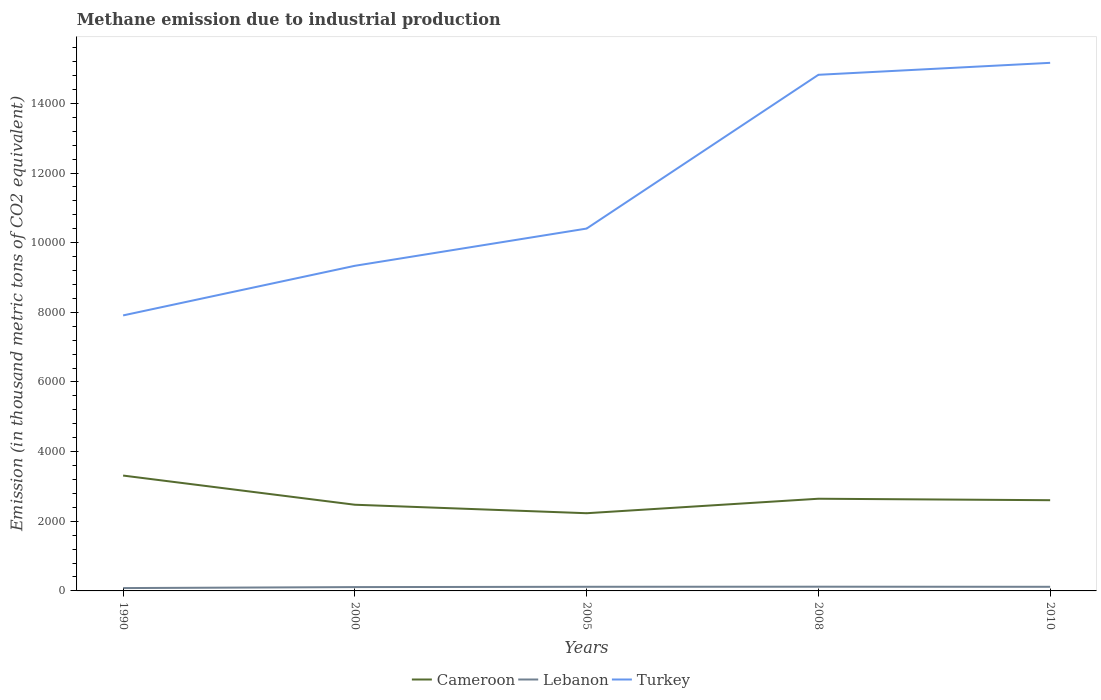Across all years, what is the maximum amount of methane emitted in Cameroon?
Make the answer very short. 2231.4. What is the difference between the highest and the second highest amount of methane emitted in Cameroon?
Make the answer very short. 1081.7. What is the difference between the highest and the lowest amount of methane emitted in Turkey?
Provide a short and direct response. 2. How many lines are there?
Keep it short and to the point. 3. What is the difference between two consecutive major ticks on the Y-axis?
Ensure brevity in your answer.  2000. Are the values on the major ticks of Y-axis written in scientific E-notation?
Give a very brief answer. No. What is the title of the graph?
Your response must be concise. Methane emission due to industrial production. What is the label or title of the X-axis?
Your answer should be very brief. Years. What is the label or title of the Y-axis?
Give a very brief answer. Emission (in thousand metric tons of CO2 equivalent). What is the Emission (in thousand metric tons of CO2 equivalent) of Cameroon in 1990?
Your response must be concise. 3313.1. What is the Emission (in thousand metric tons of CO2 equivalent) in Lebanon in 1990?
Provide a succinct answer. 81.7. What is the Emission (in thousand metric tons of CO2 equivalent) in Turkey in 1990?
Keep it short and to the point. 7912.1. What is the Emission (in thousand metric tons of CO2 equivalent) of Cameroon in 2000?
Keep it short and to the point. 2475.1. What is the Emission (in thousand metric tons of CO2 equivalent) of Lebanon in 2000?
Ensure brevity in your answer.  109.7. What is the Emission (in thousand metric tons of CO2 equivalent) in Turkey in 2000?
Keep it short and to the point. 9337. What is the Emission (in thousand metric tons of CO2 equivalent) of Cameroon in 2005?
Ensure brevity in your answer.  2231.4. What is the Emission (in thousand metric tons of CO2 equivalent) of Lebanon in 2005?
Provide a short and direct response. 119. What is the Emission (in thousand metric tons of CO2 equivalent) of Turkey in 2005?
Offer a very short reply. 1.04e+04. What is the Emission (in thousand metric tons of CO2 equivalent) in Cameroon in 2008?
Offer a very short reply. 2647.3. What is the Emission (in thousand metric tons of CO2 equivalent) of Lebanon in 2008?
Your response must be concise. 121.2. What is the Emission (in thousand metric tons of CO2 equivalent) in Turkey in 2008?
Your answer should be very brief. 1.48e+04. What is the Emission (in thousand metric tons of CO2 equivalent) in Cameroon in 2010?
Your response must be concise. 2605.4. What is the Emission (in thousand metric tons of CO2 equivalent) of Lebanon in 2010?
Keep it short and to the point. 118.4. What is the Emission (in thousand metric tons of CO2 equivalent) in Turkey in 2010?
Make the answer very short. 1.52e+04. Across all years, what is the maximum Emission (in thousand metric tons of CO2 equivalent) of Cameroon?
Keep it short and to the point. 3313.1. Across all years, what is the maximum Emission (in thousand metric tons of CO2 equivalent) of Lebanon?
Your response must be concise. 121.2. Across all years, what is the maximum Emission (in thousand metric tons of CO2 equivalent) in Turkey?
Your answer should be compact. 1.52e+04. Across all years, what is the minimum Emission (in thousand metric tons of CO2 equivalent) in Cameroon?
Ensure brevity in your answer.  2231.4. Across all years, what is the minimum Emission (in thousand metric tons of CO2 equivalent) of Lebanon?
Ensure brevity in your answer.  81.7. Across all years, what is the minimum Emission (in thousand metric tons of CO2 equivalent) in Turkey?
Provide a short and direct response. 7912.1. What is the total Emission (in thousand metric tons of CO2 equivalent) of Cameroon in the graph?
Your answer should be compact. 1.33e+04. What is the total Emission (in thousand metric tons of CO2 equivalent) in Lebanon in the graph?
Ensure brevity in your answer.  550. What is the total Emission (in thousand metric tons of CO2 equivalent) of Turkey in the graph?
Your answer should be very brief. 5.76e+04. What is the difference between the Emission (in thousand metric tons of CO2 equivalent) in Cameroon in 1990 and that in 2000?
Give a very brief answer. 838. What is the difference between the Emission (in thousand metric tons of CO2 equivalent) of Turkey in 1990 and that in 2000?
Offer a terse response. -1424.9. What is the difference between the Emission (in thousand metric tons of CO2 equivalent) of Cameroon in 1990 and that in 2005?
Offer a terse response. 1081.7. What is the difference between the Emission (in thousand metric tons of CO2 equivalent) of Lebanon in 1990 and that in 2005?
Offer a very short reply. -37.3. What is the difference between the Emission (in thousand metric tons of CO2 equivalent) of Turkey in 1990 and that in 2005?
Offer a very short reply. -2494.3. What is the difference between the Emission (in thousand metric tons of CO2 equivalent) in Cameroon in 1990 and that in 2008?
Your answer should be very brief. 665.8. What is the difference between the Emission (in thousand metric tons of CO2 equivalent) in Lebanon in 1990 and that in 2008?
Offer a very short reply. -39.5. What is the difference between the Emission (in thousand metric tons of CO2 equivalent) of Turkey in 1990 and that in 2008?
Provide a short and direct response. -6910. What is the difference between the Emission (in thousand metric tons of CO2 equivalent) of Cameroon in 1990 and that in 2010?
Your answer should be compact. 707.7. What is the difference between the Emission (in thousand metric tons of CO2 equivalent) in Lebanon in 1990 and that in 2010?
Your answer should be compact. -36.7. What is the difference between the Emission (in thousand metric tons of CO2 equivalent) of Turkey in 1990 and that in 2010?
Offer a terse response. -7253.5. What is the difference between the Emission (in thousand metric tons of CO2 equivalent) of Cameroon in 2000 and that in 2005?
Ensure brevity in your answer.  243.7. What is the difference between the Emission (in thousand metric tons of CO2 equivalent) of Lebanon in 2000 and that in 2005?
Your answer should be very brief. -9.3. What is the difference between the Emission (in thousand metric tons of CO2 equivalent) of Turkey in 2000 and that in 2005?
Give a very brief answer. -1069.4. What is the difference between the Emission (in thousand metric tons of CO2 equivalent) in Cameroon in 2000 and that in 2008?
Your answer should be compact. -172.2. What is the difference between the Emission (in thousand metric tons of CO2 equivalent) in Lebanon in 2000 and that in 2008?
Ensure brevity in your answer.  -11.5. What is the difference between the Emission (in thousand metric tons of CO2 equivalent) in Turkey in 2000 and that in 2008?
Your answer should be compact. -5485.1. What is the difference between the Emission (in thousand metric tons of CO2 equivalent) in Cameroon in 2000 and that in 2010?
Your answer should be compact. -130.3. What is the difference between the Emission (in thousand metric tons of CO2 equivalent) of Lebanon in 2000 and that in 2010?
Make the answer very short. -8.7. What is the difference between the Emission (in thousand metric tons of CO2 equivalent) of Turkey in 2000 and that in 2010?
Give a very brief answer. -5828.6. What is the difference between the Emission (in thousand metric tons of CO2 equivalent) in Cameroon in 2005 and that in 2008?
Your answer should be very brief. -415.9. What is the difference between the Emission (in thousand metric tons of CO2 equivalent) in Turkey in 2005 and that in 2008?
Offer a terse response. -4415.7. What is the difference between the Emission (in thousand metric tons of CO2 equivalent) in Cameroon in 2005 and that in 2010?
Give a very brief answer. -374. What is the difference between the Emission (in thousand metric tons of CO2 equivalent) in Turkey in 2005 and that in 2010?
Offer a very short reply. -4759.2. What is the difference between the Emission (in thousand metric tons of CO2 equivalent) in Cameroon in 2008 and that in 2010?
Provide a succinct answer. 41.9. What is the difference between the Emission (in thousand metric tons of CO2 equivalent) of Lebanon in 2008 and that in 2010?
Offer a very short reply. 2.8. What is the difference between the Emission (in thousand metric tons of CO2 equivalent) of Turkey in 2008 and that in 2010?
Your answer should be compact. -343.5. What is the difference between the Emission (in thousand metric tons of CO2 equivalent) in Cameroon in 1990 and the Emission (in thousand metric tons of CO2 equivalent) in Lebanon in 2000?
Offer a terse response. 3203.4. What is the difference between the Emission (in thousand metric tons of CO2 equivalent) of Cameroon in 1990 and the Emission (in thousand metric tons of CO2 equivalent) of Turkey in 2000?
Keep it short and to the point. -6023.9. What is the difference between the Emission (in thousand metric tons of CO2 equivalent) in Lebanon in 1990 and the Emission (in thousand metric tons of CO2 equivalent) in Turkey in 2000?
Offer a terse response. -9255.3. What is the difference between the Emission (in thousand metric tons of CO2 equivalent) of Cameroon in 1990 and the Emission (in thousand metric tons of CO2 equivalent) of Lebanon in 2005?
Make the answer very short. 3194.1. What is the difference between the Emission (in thousand metric tons of CO2 equivalent) in Cameroon in 1990 and the Emission (in thousand metric tons of CO2 equivalent) in Turkey in 2005?
Your answer should be compact. -7093.3. What is the difference between the Emission (in thousand metric tons of CO2 equivalent) of Lebanon in 1990 and the Emission (in thousand metric tons of CO2 equivalent) of Turkey in 2005?
Your response must be concise. -1.03e+04. What is the difference between the Emission (in thousand metric tons of CO2 equivalent) in Cameroon in 1990 and the Emission (in thousand metric tons of CO2 equivalent) in Lebanon in 2008?
Your response must be concise. 3191.9. What is the difference between the Emission (in thousand metric tons of CO2 equivalent) of Cameroon in 1990 and the Emission (in thousand metric tons of CO2 equivalent) of Turkey in 2008?
Offer a terse response. -1.15e+04. What is the difference between the Emission (in thousand metric tons of CO2 equivalent) in Lebanon in 1990 and the Emission (in thousand metric tons of CO2 equivalent) in Turkey in 2008?
Offer a very short reply. -1.47e+04. What is the difference between the Emission (in thousand metric tons of CO2 equivalent) in Cameroon in 1990 and the Emission (in thousand metric tons of CO2 equivalent) in Lebanon in 2010?
Keep it short and to the point. 3194.7. What is the difference between the Emission (in thousand metric tons of CO2 equivalent) in Cameroon in 1990 and the Emission (in thousand metric tons of CO2 equivalent) in Turkey in 2010?
Provide a succinct answer. -1.19e+04. What is the difference between the Emission (in thousand metric tons of CO2 equivalent) in Lebanon in 1990 and the Emission (in thousand metric tons of CO2 equivalent) in Turkey in 2010?
Provide a succinct answer. -1.51e+04. What is the difference between the Emission (in thousand metric tons of CO2 equivalent) of Cameroon in 2000 and the Emission (in thousand metric tons of CO2 equivalent) of Lebanon in 2005?
Make the answer very short. 2356.1. What is the difference between the Emission (in thousand metric tons of CO2 equivalent) of Cameroon in 2000 and the Emission (in thousand metric tons of CO2 equivalent) of Turkey in 2005?
Your answer should be compact. -7931.3. What is the difference between the Emission (in thousand metric tons of CO2 equivalent) of Lebanon in 2000 and the Emission (in thousand metric tons of CO2 equivalent) of Turkey in 2005?
Your answer should be very brief. -1.03e+04. What is the difference between the Emission (in thousand metric tons of CO2 equivalent) of Cameroon in 2000 and the Emission (in thousand metric tons of CO2 equivalent) of Lebanon in 2008?
Your answer should be very brief. 2353.9. What is the difference between the Emission (in thousand metric tons of CO2 equivalent) in Cameroon in 2000 and the Emission (in thousand metric tons of CO2 equivalent) in Turkey in 2008?
Keep it short and to the point. -1.23e+04. What is the difference between the Emission (in thousand metric tons of CO2 equivalent) in Lebanon in 2000 and the Emission (in thousand metric tons of CO2 equivalent) in Turkey in 2008?
Keep it short and to the point. -1.47e+04. What is the difference between the Emission (in thousand metric tons of CO2 equivalent) in Cameroon in 2000 and the Emission (in thousand metric tons of CO2 equivalent) in Lebanon in 2010?
Your response must be concise. 2356.7. What is the difference between the Emission (in thousand metric tons of CO2 equivalent) of Cameroon in 2000 and the Emission (in thousand metric tons of CO2 equivalent) of Turkey in 2010?
Offer a very short reply. -1.27e+04. What is the difference between the Emission (in thousand metric tons of CO2 equivalent) of Lebanon in 2000 and the Emission (in thousand metric tons of CO2 equivalent) of Turkey in 2010?
Offer a very short reply. -1.51e+04. What is the difference between the Emission (in thousand metric tons of CO2 equivalent) in Cameroon in 2005 and the Emission (in thousand metric tons of CO2 equivalent) in Lebanon in 2008?
Provide a short and direct response. 2110.2. What is the difference between the Emission (in thousand metric tons of CO2 equivalent) in Cameroon in 2005 and the Emission (in thousand metric tons of CO2 equivalent) in Turkey in 2008?
Keep it short and to the point. -1.26e+04. What is the difference between the Emission (in thousand metric tons of CO2 equivalent) of Lebanon in 2005 and the Emission (in thousand metric tons of CO2 equivalent) of Turkey in 2008?
Provide a succinct answer. -1.47e+04. What is the difference between the Emission (in thousand metric tons of CO2 equivalent) in Cameroon in 2005 and the Emission (in thousand metric tons of CO2 equivalent) in Lebanon in 2010?
Your response must be concise. 2113. What is the difference between the Emission (in thousand metric tons of CO2 equivalent) of Cameroon in 2005 and the Emission (in thousand metric tons of CO2 equivalent) of Turkey in 2010?
Offer a terse response. -1.29e+04. What is the difference between the Emission (in thousand metric tons of CO2 equivalent) of Lebanon in 2005 and the Emission (in thousand metric tons of CO2 equivalent) of Turkey in 2010?
Your response must be concise. -1.50e+04. What is the difference between the Emission (in thousand metric tons of CO2 equivalent) in Cameroon in 2008 and the Emission (in thousand metric tons of CO2 equivalent) in Lebanon in 2010?
Keep it short and to the point. 2528.9. What is the difference between the Emission (in thousand metric tons of CO2 equivalent) in Cameroon in 2008 and the Emission (in thousand metric tons of CO2 equivalent) in Turkey in 2010?
Your answer should be very brief. -1.25e+04. What is the difference between the Emission (in thousand metric tons of CO2 equivalent) of Lebanon in 2008 and the Emission (in thousand metric tons of CO2 equivalent) of Turkey in 2010?
Keep it short and to the point. -1.50e+04. What is the average Emission (in thousand metric tons of CO2 equivalent) in Cameroon per year?
Provide a succinct answer. 2654.46. What is the average Emission (in thousand metric tons of CO2 equivalent) of Lebanon per year?
Your answer should be compact. 110. What is the average Emission (in thousand metric tons of CO2 equivalent) of Turkey per year?
Offer a very short reply. 1.15e+04. In the year 1990, what is the difference between the Emission (in thousand metric tons of CO2 equivalent) in Cameroon and Emission (in thousand metric tons of CO2 equivalent) in Lebanon?
Give a very brief answer. 3231.4. In the year 1990, what is the difference between the Emission (in thousand metric tons of CO2 equivalent) of Cameroon and Emission (in thousand metric tons of CO2 equivalent) of Turkey?
Your response must be concise. -4599. In the year 1990, what is the difference between the Emission (in thousand metric tons of CO2 equivalent) of Lebanon and Emission (in thousand metric tons of CO2 equivalent) of Turkey?
Provide a succinct answer. -7830.4. In the year 2000, what is the difference between the Emission (in thousand metric tons of CO2 equivalent) in Cameroon and Emission (in thousand metric tons of CO2 equivalent) in Lebanon?
Provide a short and direct response. 2365.4. In the year 2000, what is the difference between the Emission (in thousand metric tons of CO2 equivalent) in Cameroon and Emission (in thousand metric tons of CO2 equivalent) in Turkey?
Offer a terse response. -6861.9. In the year 2000, what is the difference between the Emission (in thousand metric tons of CO2 equivalent) in Lebanon and Emission (in thousand metric tons of CO2 equivalent) in Turkey?
Offer a very short reply. -9227.3. In the year 2005, what is the difference between the Emission (in thousand metric tons of CO2 equivalent) in Cameroon and Emission (in thousand metric tons of CO2 equivalent) in Lebanon?
Give a very brief answer. 2112.4. In the year 2005, what is the difference between the Emission (in thousand metric tons of CO2 equivalent) in Cameroon and Emission (in thousand metric tons of CO2 equivalent) in Turkey?
Your response must be concise. -8175. In the year 2005, what is the difference between the Emission (in thousand metric tons of CO2 equivalent) of Lebanon and Emission (in thousand metric tons of CO2 equivalent) of Turkey?
Provide a short and direct response. -1.03e+04. In the year 2008, what is the difference between the Emission (in thousand metric tons of CO2 equivalent) in Cameroon and Emission (in thousand metric tons of CO2 equivalent) in Lebanon?
Keep it short and to the point. 2526.1. In the year 2008, what is the difference between the Emission (in thousand metric tons of CO2 equivalent) of Cameroon and Emission (in thousand metric tons of CO2 equivalent) of Turkey?
Make the answer very short. -1.22e+04. In the year 2008, what is the difference between the Emission (in thousand metric tons of CO2 equivalent) in Lebanon and Emission (in thousand metric tons of CO2 equivalent) in Turkey?
Your answer should be very brief. -1.47e+04. In the year 2010, what is the difference between the Emission (in thousand metric tons of CO2 equivalent) of Cameroon and Emission (in thousand metric tons of CO2 equivalent) of Lebanon?
Make the answer very short. 2487. In the year 2010, what is the difference between the Emission (in thousand metric tons of CO2 equivalent) of Cameroon and Emission (in thousand metric tons of CO2 equivalent) of Turkey?
Provide a succinct answer. -1.26e+04. In the year 2010, what is the difference between the Emission (in thousand metric tons of CO2 equivalent) of Lebanon and Emission (in thousand metric tons of CO2 equivalent) of Turkey?
Keep it short and to the point. -1.50e+04. What is the ratio of the Emission (in thousand metric tons of CO2 equivalent) in Cameroon in 1990 to that in 2000?
Provide a short and direct response. 1.34. What is the ratio of the Emission (in thousand metric tons of CO2 equivalent) of Lebanon in 1990 to that in 2000?
Your answer should be very brief. 0.74. What is the ratio of the Emission (in thousand metric tons of CO2 equivalent) in Turkey in 1990 to that in 2000?
Your answer should be very brief. 0.85. What is the ratio of the Emission (in thousand metric tons of CO2 equivalent) of Cameroon in 1990 to that in 2005?
Offer a very short reply. 1.48. What is the ratio of the Emission (in thousand metric tons of CO2 equivalent) in Lebanon in 1990 to that in 2005?
Ensure brevity in your answer.  0.69. What is the ratio of the Emission (in thousand metric tons of CO2 equivalent) in Turkey in 1990 to that in 2005?
Give a very brief answer. 0.76. What is the ratio of the Emission (in thousand metric tons of CO2 equivalent) of Cameroon in 1990 to that in 2008?
Provide a short and direct response. 1.25. What is the ratio of the Emission (in thousand metric tons of CO2 equivalent) of Lebanon in 1990 to that in 2008?
Keep it short and to the point. 0.67. What is the ratio of the Emission (in thousand metric tons of CO2 equivalent) of Turkey in 1990 to that in 2008?
Provide a short and direct response. 0.53. What is the ratio of the Emission (in thousand metric tons of CO2 equivalent) in Cameroon in 1990 to that in 2010?
Provide a succinct answer. 1.27. What is the ratio of the Emission (in thousand metric tons of CO2 equivalent) of Lebanon in 1990 to that in 2010?
Give a very brief answer. 0.69. What is the ratio of the Emission (in thousand metric tons of CO2 equivalent) of Turkey in 1990 to that in 2010?
Provide a succinct answer. 0.52. What is the ratio of the Emission (in thousand metric tons of CO2 equivalent) of Cameroon in 2000 to that in 2005?
Give a very brief answer. 1.11. What is the ratio of the Emission (in thousand metric tons of CO2 equivalent) in Lebanon in 2000 to that in 2005?
Give a very brief answer. 0.92. What is the ratio of the Emission (in thousand metric tons of CO2 equivalent) in Turkey in 2000 to that in 2005?
Keep it short and to the point. 0.9. What is the ratio of the Emission (in thousand metric tons of CO2 equivalent) of Cameroon in 2000 to that in 2008?
Your response must be concise. 0.94. What is the ratio of the Emission (in thousand metric tons of CO2 equivalent) of Lebanon in 2000 to that in 2008?
Your answer should be very brief. 0.91. What is the ratio of the Emission (in thousand metric tons of CO2 equivalent) of Turkey in 2000 to that in 2008?
Make the answer very short. 0.63. What is the ratio of the Emission (in thousand metric tons of CO2 equivalent) of Cameroon in 2000 to that in 2010?
Provide a succinct answer. 0.95. What is the ratio of the Emission (in thousand metric tons of CO2 equivalent) in Lebanon in 2000 to that in 2010?
Provide a succinct answer. 0.93. What is the ratio of the Emission (in thousand metric tons of CO2 equivalent) of Turkey in 2000 to that in 2010?
Offer a terse response. 0.62. What is the ratio of the Emission (in thousand metric tons of CO2 equivalent) in Cameroon in 2005 to that in 2008?
Keep it short and to the point. 0.84. What is the ratio of the Emission (in thousand metric tons of CO2 equivalent) of Lebanon in 2005 to that in 2008?
Offer a terse response. 0.98. What is the ratio of the Emission (in thousand metric tons of CO2 equivalent) of Turkey in 2005 to that in 2008?
Your answer should be very brief. 0.7. What is the ratio of the Emission (in thousand metric tons of CO2 equivalent) in Cameroon in 2005 to that in 2010?
Offer a terse response. 0.86. What is the ratio of the Emission (in thousand metric tons of CO2 equivalent) in Turkey in 2005 to that in 2010?
Your answer should be compact. 0.69. What is the ratio of the Emission (in thousand metric tons of CO2 equivalent) in Cameroon in 2008 to that in 2010?
Make the answer very short. 1.02. What is the ratio of the Emission (in thousand metric tons of CO2 equivalent) in Lebanon in 2008 to that in 2010?
Provide a succinct answer. 1.02. What is the ratio of the Emission (in thousand metric tons of CO2 equivalent) in Turkey in 2008 to that in 2010?
Keep it short and to the point. 0.98. What is the difference between the highest and the second highest Emission (in thousand metric tons of CO2 equivalent) in Cameroon?
Give a very brief answer. 665.8. What is the difference between the highest and the second highest Emission (in thousand metric tons of CO2 equivalent) in Turkey?
Offer a terse response. 343.5. What is the difference between the highest and the lowest Emission (in thousand metric tons of CO2 equivalent) in Cameroon?
Give a very brief answer. 1081.7. What is the difference between the highest and the lowest Emission (in thousand metric tons of CO2 equivalent) of Lebanon?
Provide a short and direct response. 39.5. What is the difference between the highest and the lowest Emission (in thousand metric tons of CO2 equivalent) in Turkey?
Offer a very short reply. 7253.5. 